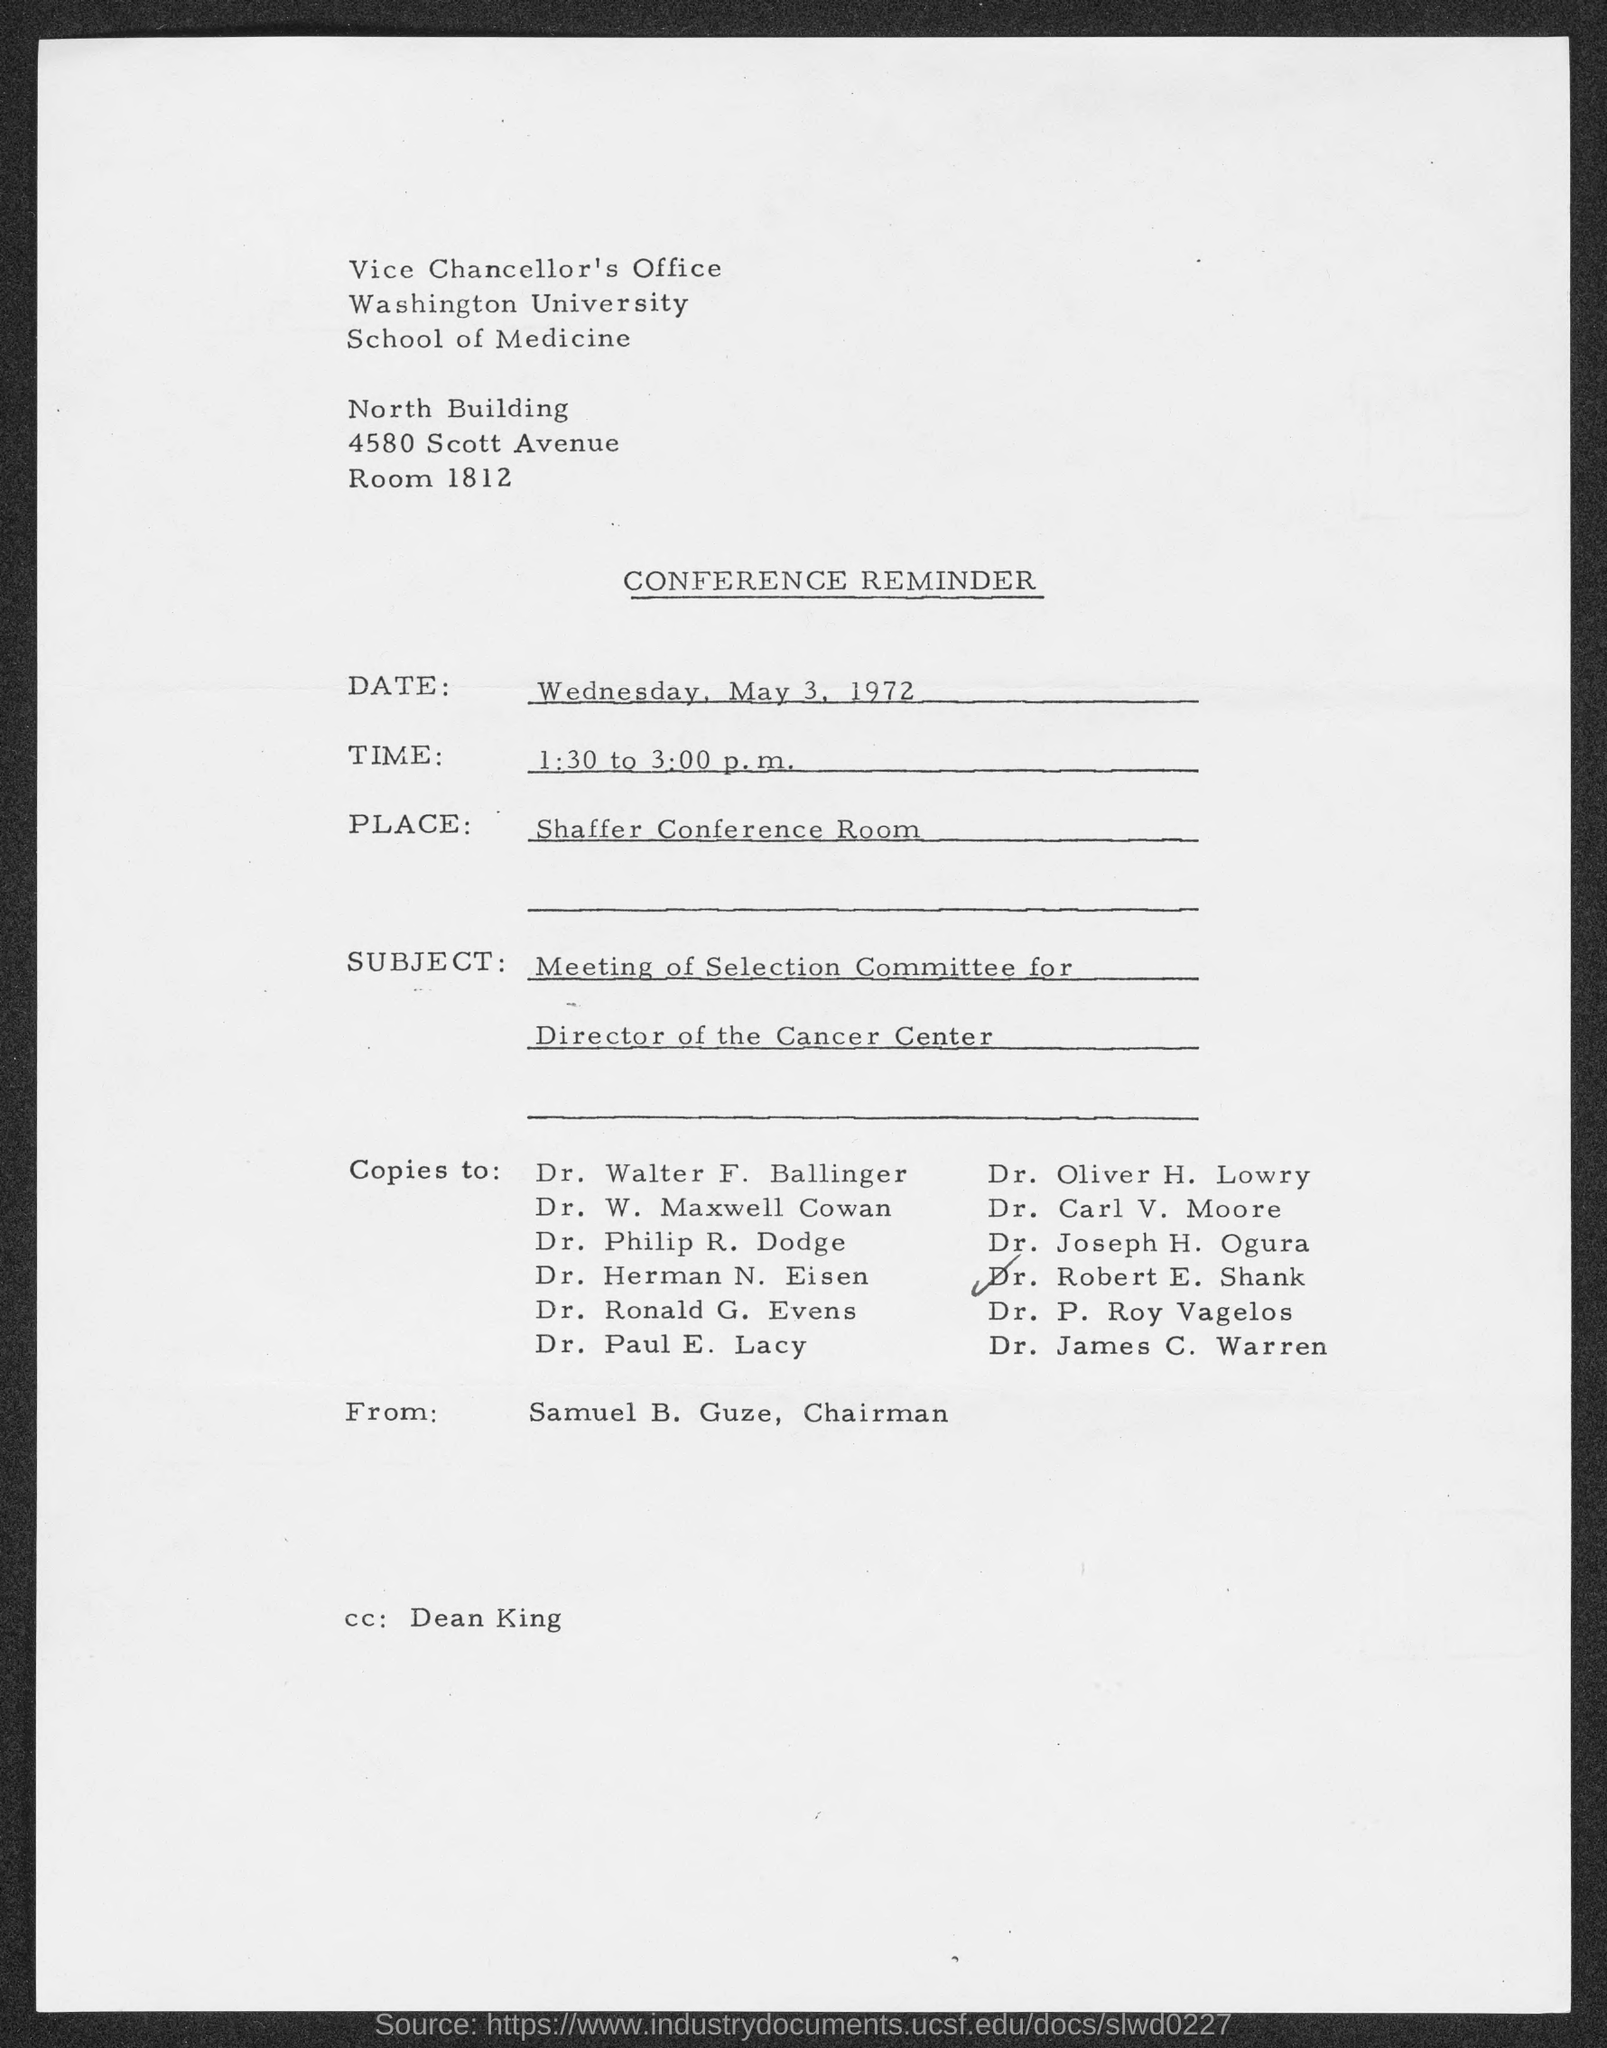Highlight a few significant elements in this photo. The individual identified as "CC" in the email is Dean King. The room number is 1812. The conference reminder is scheduled to occur from 1:30 to 3:00 p.m. 